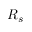<formula> <loc_0><loc_0><loc_500><loc_500>R _ { s }</formula> 